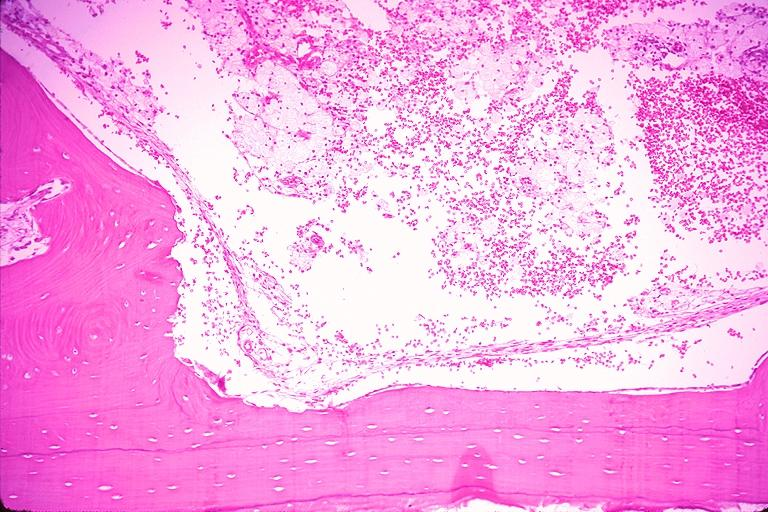does odontoid process subluxation with narrowing of foramen magnum show traumatic bone cyst simple bone cyst?
Answer the question using a single word or phrase. No 